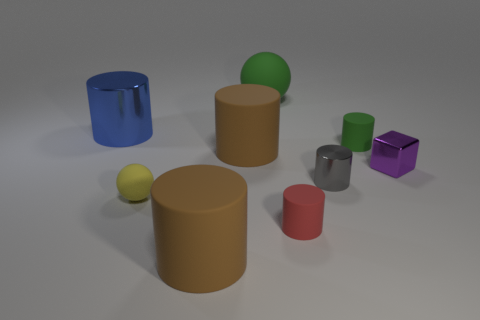Are there any purple metal objects that have the same size as the yellow matte object?
Provide a succinct answer. Yes. Is the number of big green balls right of the tiny shiny cylinder the same as the number of metallic blocks?
Provide a short and direct response. No. How big is the blue cylinder?
Give a very brief answer. Large. There is a green object on the left side of the tiny gray shiny object; what number of green matte objects are behind it?
Keep it short and to the point. 0. There is a metal thing that is to the right of the small ball and to the left of the small purple shiny block; what shape is it?
Your answer should be compact. Cylinder. How many matte things have the same color as the shiny cube?
Your response must be concise. 0. There is a tiny matte cylinder that is in front of the green rubber thing that is right of the large green matte thing; is there a object on the left side of it?
Your response must be concise. Yes. There is a cylinder that is both left of the large matte sphere and in front of the purple metallic object; how big is it?
Ensure brevity in your answer.  Large. What number of small yellow spheres have the same material as the tiny gray thing?
Your answer should be very brief. 0. What number of cylinders are either big green things or tiny green objects?
Make the answer very short. 1. 